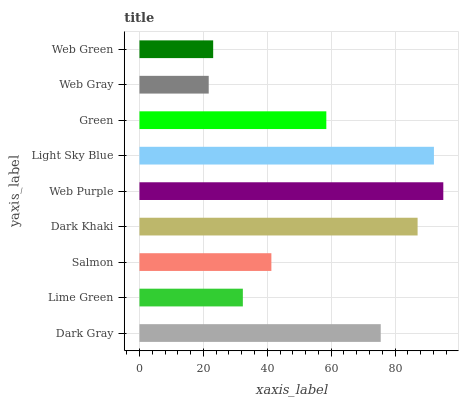Is Web Gray the minimum?
Answer yes or no. Yes. Is Web Purple the maximum?
Answer yes or no. Yes. Is Lime Green the minimum?
Answer yes or no. No. Is Lime Green the maximum?
Answer yes or no. No. Is Dark Gray greater than Lime Green?
Answer yes or no. Yes. Is Lime Green less than Dark Gray?
Answer yes or no. Yes. Is Lime Green greater than Dark Gray?
Answer yes or no. No. Is Dark Gray less than Lime Green?
Answer yes or no. No. Is Green the high median?
Answer yes or no. Yes. Is Green the low median?
Answer yes or no. Yes. Is Web Purple the high median?
Answer yes or no. No. Is Salmon the low median?
Answer yes or no. No. 